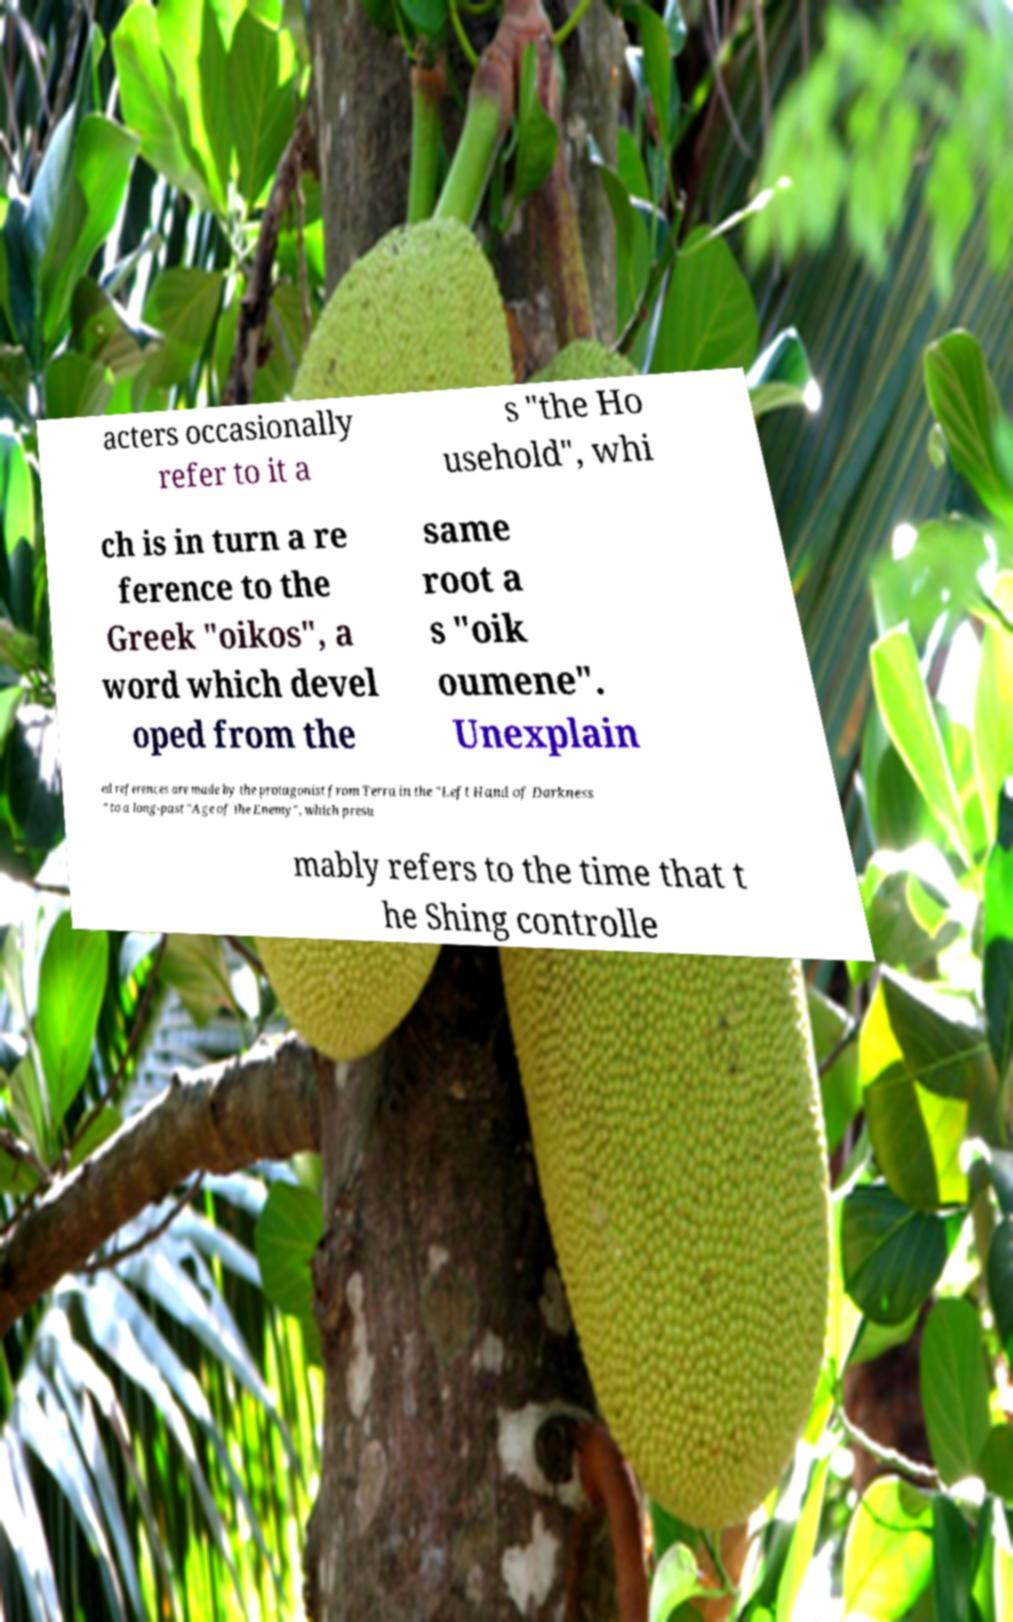For documentation purposes, I need the text within this image transcribed. Could you provide that? acters occasionally refer to it a s "the Ho usehold", whi ch is in turn a re ference to the Greek "oikos", a word which devel oped from the same root a s "oik oumene". Unexplain ed references are made by the protagonist from Terra in the "Left Hand of Darkness " to a long-past "Age of the Enemy", which presu mably refers to the time that t he Shing controlle 